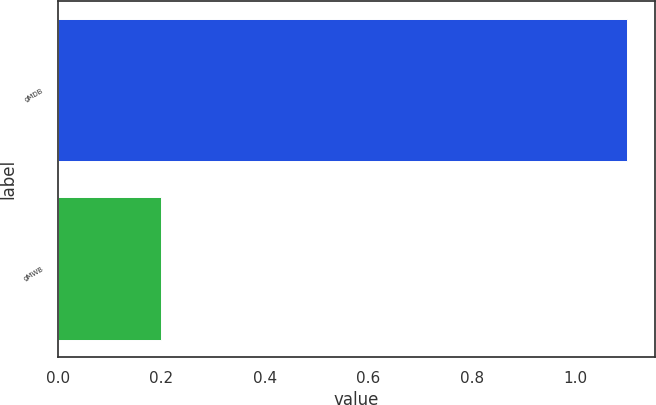Convert chart to OTSL. <chart><loc_0><loc_0><loc_500><loc_500><bar_chart><fcel>gMDB<fcel>gMWB<nl><fcel>1.1<fcel>0.2<nl></chart> 